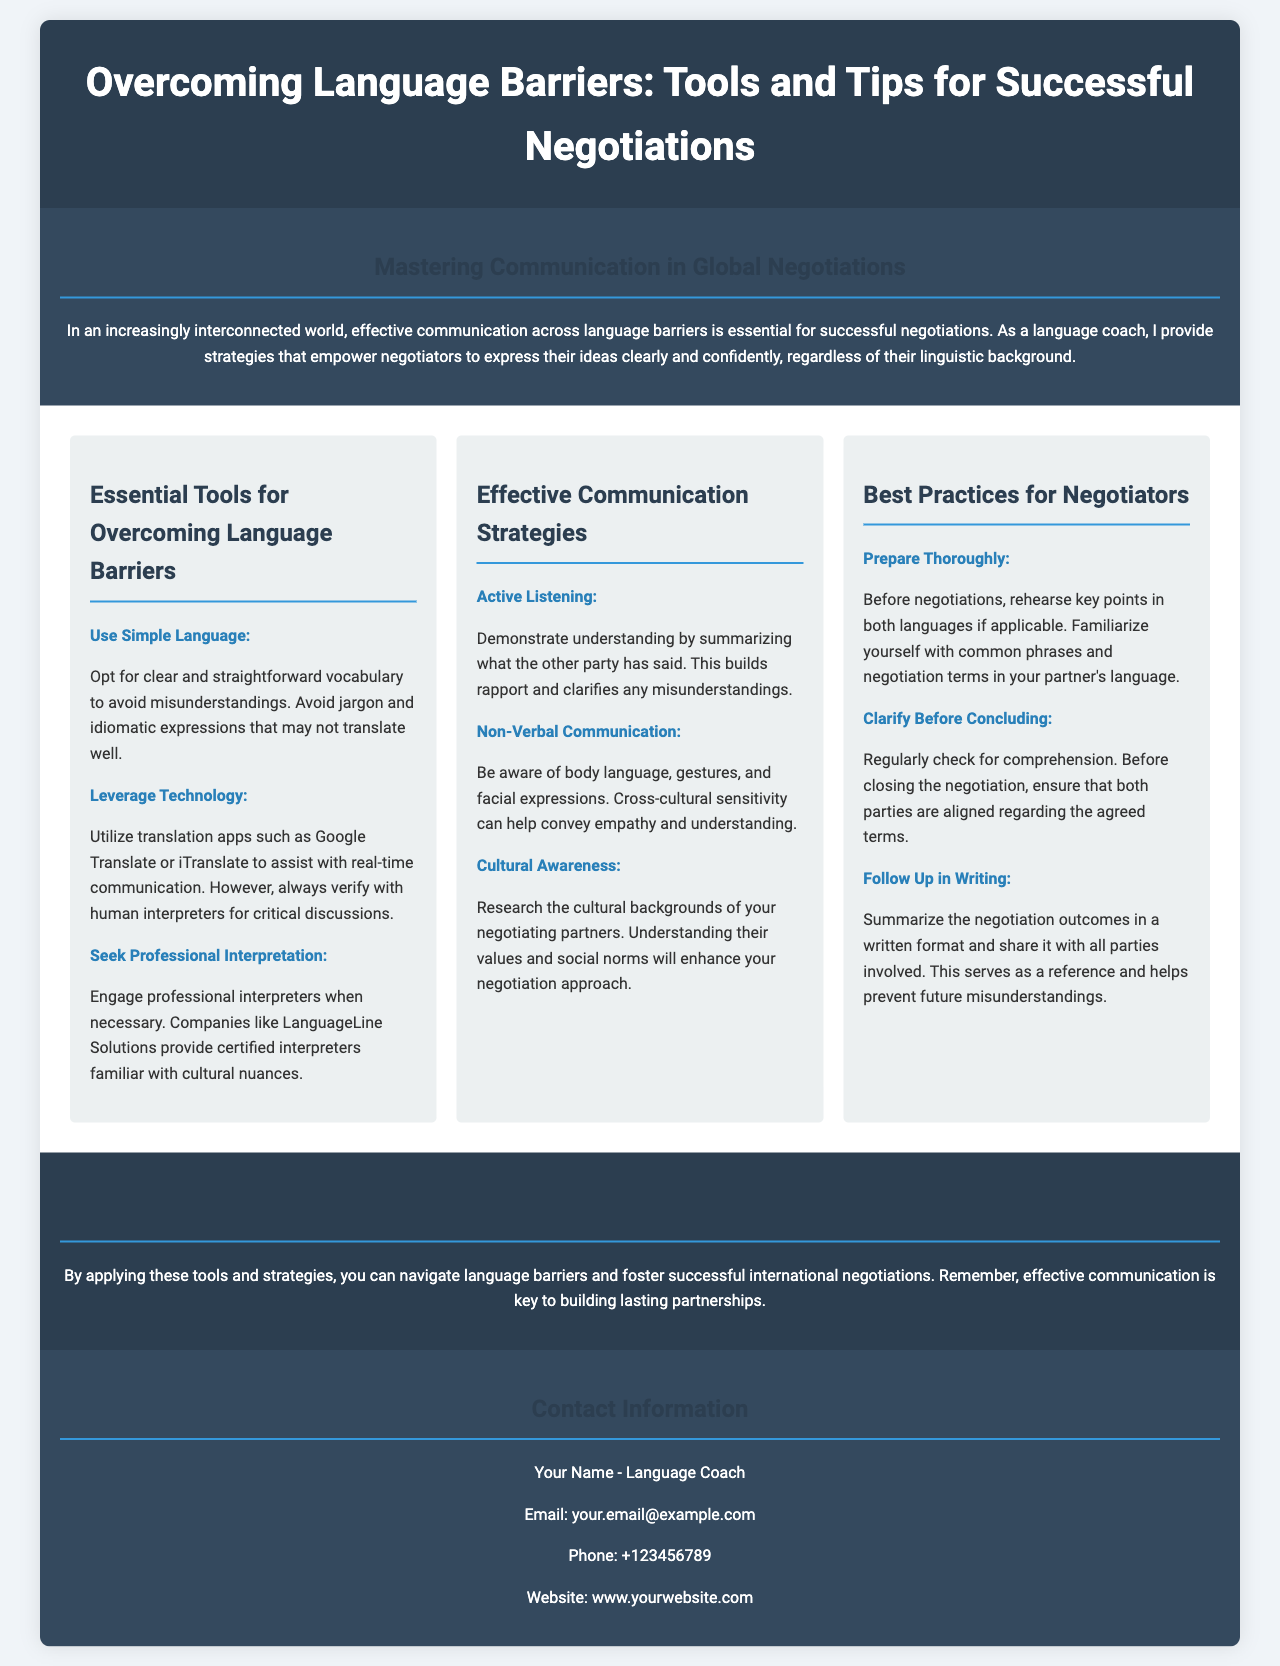what is the title of the brochure? The title is prominently displayed at the top of the brochure.
Answer: Overcoming Language Barriers: Tools and Tips for Successful Negotiations what is a recommended tool for real-time communication? This tool is mentioned in the section on essential tools for overcoming language barriers.
Answer: Google Translate who should be engaged for professional interpretation? This is specified in the corresponding section on tools for overcoming language barriers.
Answer: LanguageLine Solutions what is one aspect of effective communication strategies? This question refers to strategies listed in the respective section of the brochure.
Answer: Active Listening what is the contact email provided in the brochure? The contact email is located within the contact information section of the document.
Answer: your.email@example.com how can negotiators confirm understanding before concluding? This advice is detailed in the best practices for negotiators section.
Answer: Clarify Before Concluding what is emphasized as essential for successful negotiations? This important belief is highlighted in the conclusion of the brochure.
Answer: Effective communication what should be done with the negotiation outcomes? This practice is explained in the best practices section of the brochure.
Answer: Follow Up in Writing what color is the header background? This information is descriptive of the design of the brochure.
Answer: Dark blue 